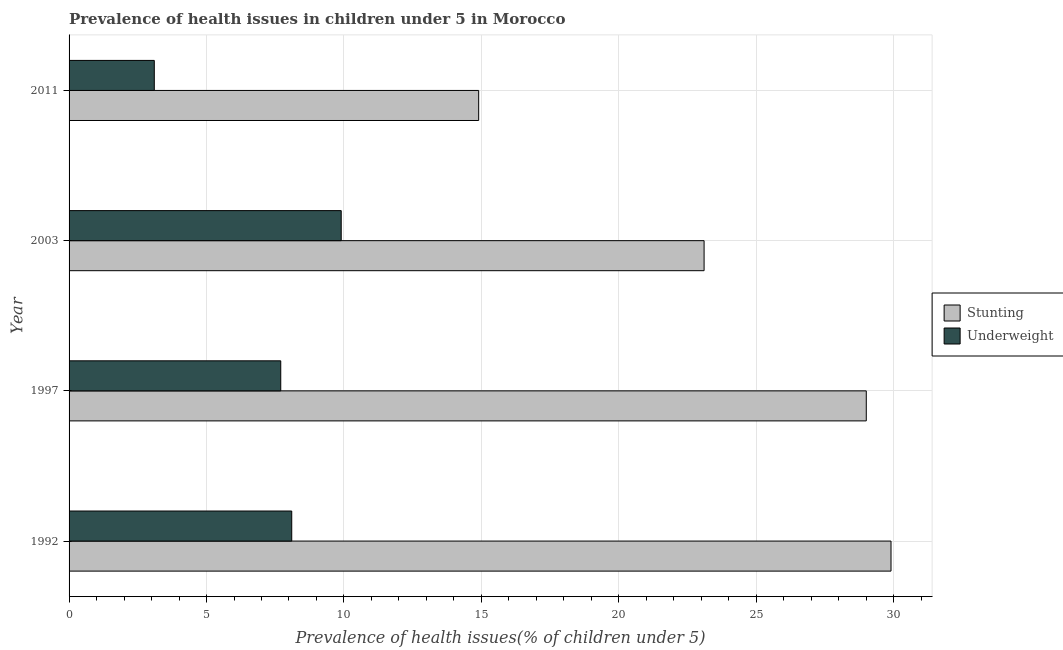How many bars are there on the 3rd tick from the top?
Offer a terse response. 2. What is the label of the 3rd group of bars from the top?
Provide a short and direct response. 1997. In how many cases, is the number of bars for a given year not equal to the number of legend labels?
Ensure brevity in your answer.  0. What is the percentage of underweight children in 1997?
Your answer should be compact. 7.7. Across all years, what is the maximum percentage of underweight children?
Offer a very short reply. 9.9. Across all years, what is the minimum percentage of underweight children?
Ensure brevity in your answer.  3.1. In which year was the percentage of stunted children minimum?
Give a very brief answer. 2011. What is the total percentage of stunted children in the graph?
Give a very brief answer. 96.9. What is the difference between the percentage of stunted children in 1992 and that in 1997?
Ensure brevity in your answer.  0.9. What is the difference between the percentage of underweight children in 2003 and the percentage of stunted children in 1997?
Make the answer very short. -19.1. What is the average percentage of stunted children per year?
Give a very brief answer. 24.23. In the year 1992, what is the difference between the percentage of underweight children and percentage of stunted children?
Offer a terse response. -21.8. In how many years, is the percentage of stunted children greater than 28 %?
Your answer should be compact. 2. What is the ratio of the percentage of stunted children in 1992 to that in 2011?
Provide a succinct answer. 2.01. Is the percentage of stunted children in 1997 less than that in 2003?
Your response must be concise. No. What is the difference between the highest and the second highest percentage of underweight children?
Your answer should be compact. 1.8. What does the 2nd bar from the top in 1992 represents?
Ensure brevity in your answer.  Stunting. What does the 1st bar from the bottom in 1992 represents?
Make the answer very short. Stunting. How many bars are there?
Provide a succinct answer. 8. Are all the bars in the graph horizontal?
Your answer should be very brief. Yes. Are the values on the major ticks of X-axis written in scientific E-notation?
Provide a short and direct response. No. Does the graph contain any zero values?
Offer a very short reply. No. How are the legend labels stacked?
Keep it short and to the point. Vertical. What is the title of the graph?
Your answer should be compact. Prevalence of health issues in children under 5 in Morocco. Does "Methane emissions" appear as one of the legend labels in the graph?
Keep it short and to the point. No. What is the label or title of the X-axis?
Provide a short and direct response. Prevalence of health issues(% of children under 5). What is the label or title of the Y-axis?
Ensure brevity in your answer.  Year. What is the Prevalence of health issues(% of children under 5) in Stunting in 1992?
Provide a short and direct response. 29.9. What is the Prevalence of health issues(% of children under 5) in Underweight in 1992?
Provide a short and direct response. 8.1. What is the Prevalence of health issues(% of children under 5) of Stunting in 1997?
Your answer should be compact. 29. What is the Prevalence of health issues(% of children under 5) of Underweight in 1997?
Provide a short and direct response. 7.7. What is the Prevalence of health issues(% of children under 5) in Stunting in 2003?
Ensure brevity in your answer.  23.1. What is the Prevalence of health issues(% of children under 5) of Underweight in 2003?
Your response must be concise. 9.9. What is the Prevalence of health issues(% of children under 5) of Stunting in 2011?
Your response must be concise. 14.9. What is the Prevalence of health issues(% of children under 5) in Underweight in 2011?
Your answer should be compact. 3.1. Across all years, what is the maximum Prevalence of health issues(% of children under 5) in Stunting?
Your answer should be compact. 29.9. Across all years, what is the maximum Prevalence of health issues(% of children under 5) in Underweight?
Make the answer very short. 9.9. Across all years, what is the minimum Prevalence of health issues(% of children under 5) in Stunting?
Offer a very short reply. 14.9. Across all years, what is the minimum Prevalence of health issues(% of children under 5) in Underweight?
Make the answer very short. 3.1. What is the total Prevalence of health issues(% of children under 5) in Stunting in the graph?
Offer a very short reply. 96.9. What is the total Prevalence of health issues(% of children under 5) of Underweight in the graph?
Give a very brief answer. 28.8. What is the difference between the Prevalence of health issues(% of children under 5) in Underweight in 1992 and that in 1997?
Your response must be concise. 0.4. What is the difference between the Prevalence of health issues(% of children under 5) in Underweight in 1992 and that in 2003?
Offer a very short reply. -1.8. What is the difference between the Prevalence of health issues(% of children under 5) in Underweight in 1997 and that in 2003?
Your response must be concise. -2.2. What is the difference between the Prevalence of health issues(% of children under 5) in Underweight in 1997 and that in 2011?
Your answer should be very brief. 4.6. What is the difference between the Prevalence of health issues(% of children under 5) in Underweight in 2003 and that in 2011?
Ensure brevity in your answer.  6.8. What is the difference between the Prevalence of health issues(% of children under 5) in Stunting in 1992 and the Prevalence of health issues(% of children under 5) in Underweight in 1997?
Offer a terse response. 22.2. What is the difference between the Prevalence of health issues(% of children under 5) in Stunting in 1992 and the Prevalence of health issues(% of children under 5) in Underweight in 2011?
Your response must be concise. 26.8. What is the difference between the Prevalence of health issues(% of children under 5) of Stunting in 1997 and the Prevalence of health issues(% of children under 5) of Underweight in 2011?
Your answer should be very brief. 25.9. What is the average Prevalence of health issues(% of children under 5) in Stunting per year?
Provide a succinct answer. 24.23. In the year 1992, what is the difference between the Prevalence of health issues(% of children under 5) of Stunting and Prevalence of health issues(% of children under 5) of Underweight?
Your answer should be compact. 21.8. In the year 1997, what is the difference between the Prevalence of health issues(% of children under 5) of Stunting and Prevalence of health issues(% of children under 5) of Underweight?
Make the answer very short. 21.3. In the year 2011, what is the difference between the Prevalence of health issues(% of children under 5) in Stunting and Prevalence of health issues(% of children under 5) in Underweight?
Give a very brief answer. 11.8. What is the ratio of the Prevalence of health issues(% of children under 5) of Stunting in 1992 to that in 1997?
Your answer should be compact. 1.03. What is the ratio of the Prevalence of health issues(% of children under 5) in Underweight in 1992 to that in 1997?
Ensure brevity in your answer.  1.05. What is the ratio of the Prevalence of health issues(% of children under 5) in Stunting in 1992 to that in 2003?
Your response must be concise. 1.29. What is the ratio of the Prevalence of health issues(% of children under 5) of Underweight in 1992 to that in 2003?
Your answer should be compact. 0.82. What is the ratio of the Prevalence of health issues(% of children under 5) of Stunting in 1992 to that in 2011?
Give a very brief answer. 2.01. What is the ratio of the Prevalence of health issues(% of children under 5) of Underweight in 1992 to that in 2011?
Make the answer very short. 2.61. What is the ratio of the Prevalence of health issues(% of children under 5) of Stunting in 1997 to that in 2003?
Provide a succinct answer. 1.26. What is the ratio of the Prevalence of health issues(% of children under 5) of Stunting in 1997 to that in 2011?
Your response must be concise. 1.95. What is the ratio of the Prevalence of health issues(% of children under 5) of Underweight in 1997 to that in 2011?
Your answer should be compact. 2.48. What is the ratio of the Prevalence of health issues(% of children under 5) of Stunting in 2003 to that in 2011?
Your answer should be very brief. 1.55. What is the ratio of the Prevalence of health issues(% of children under 5) of Underweight in 2003 to that in 2011?
Ensure brevity in your answer.  3.19. What is the difference between the highest and the second highest Prevalence of health issues(% of children under 5) of Stunting?
Provide a succinct answer. 0.9. What is the difference between the highest and the second highest Prevalence of health issues(% of children under 5) in Underweight?
Make the answer very short. 1.8. What is the difference between the highest and the lowest Prevalence of health issues(% of children under 5) in Stunting?
Offer a terse response. 15. What is the difference between the highest and the lowest Prevalence of health issues(% of children under 5) in Underweight?
Make the answer very short. 6.8. 